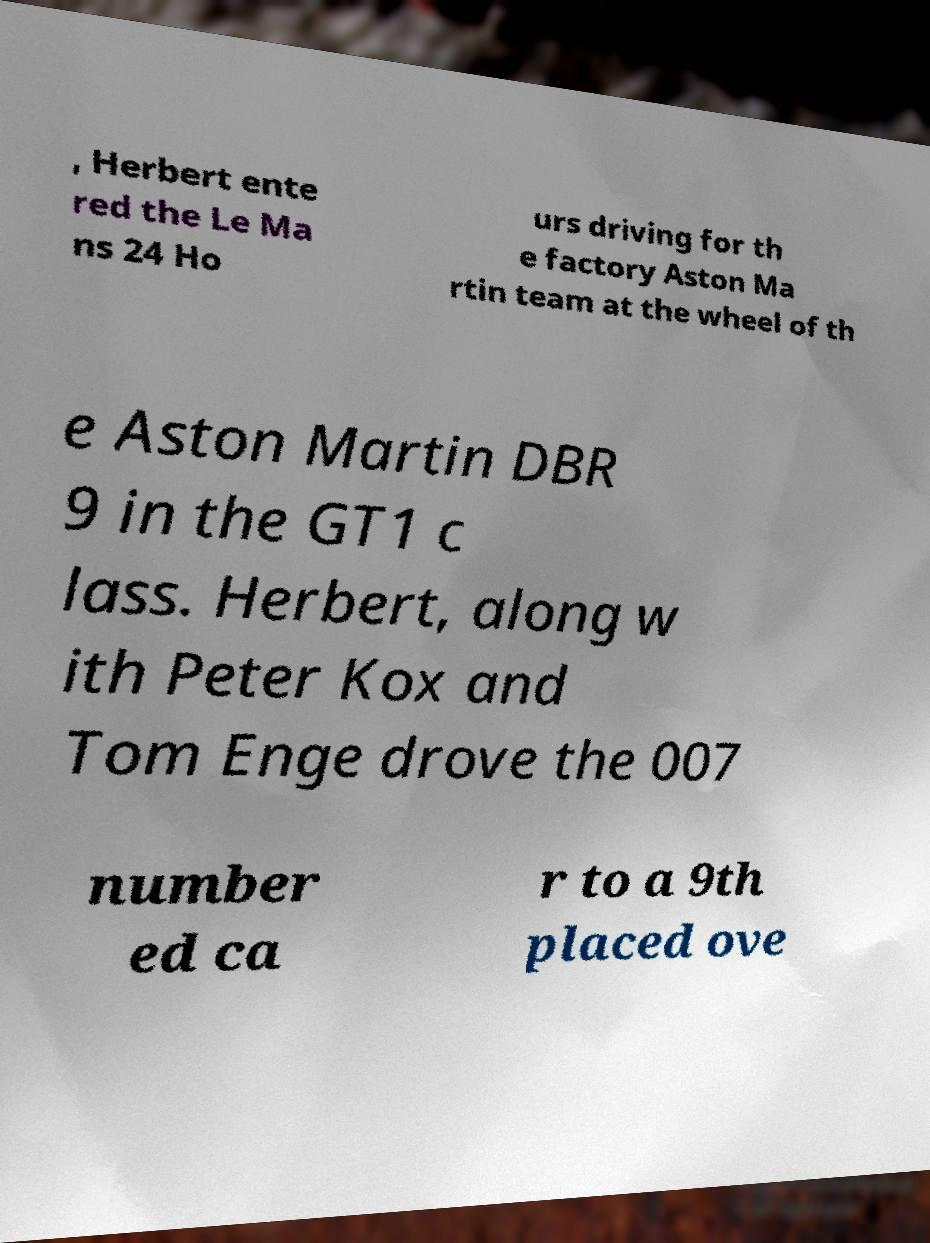There's text embedded in this image that I need extracted. Can you transcribe it verbatim? , Herbert ente red the Le Ma ns 24 Ho urs driving for th e factory Aston Ma rtin team at the wheel of th e Aston Martin DBR 9 in the GT1 c lass. Herbert, along w ith Peter Kox and Tom Enge drove the 007 number ed ca r to a 9th placed ove 